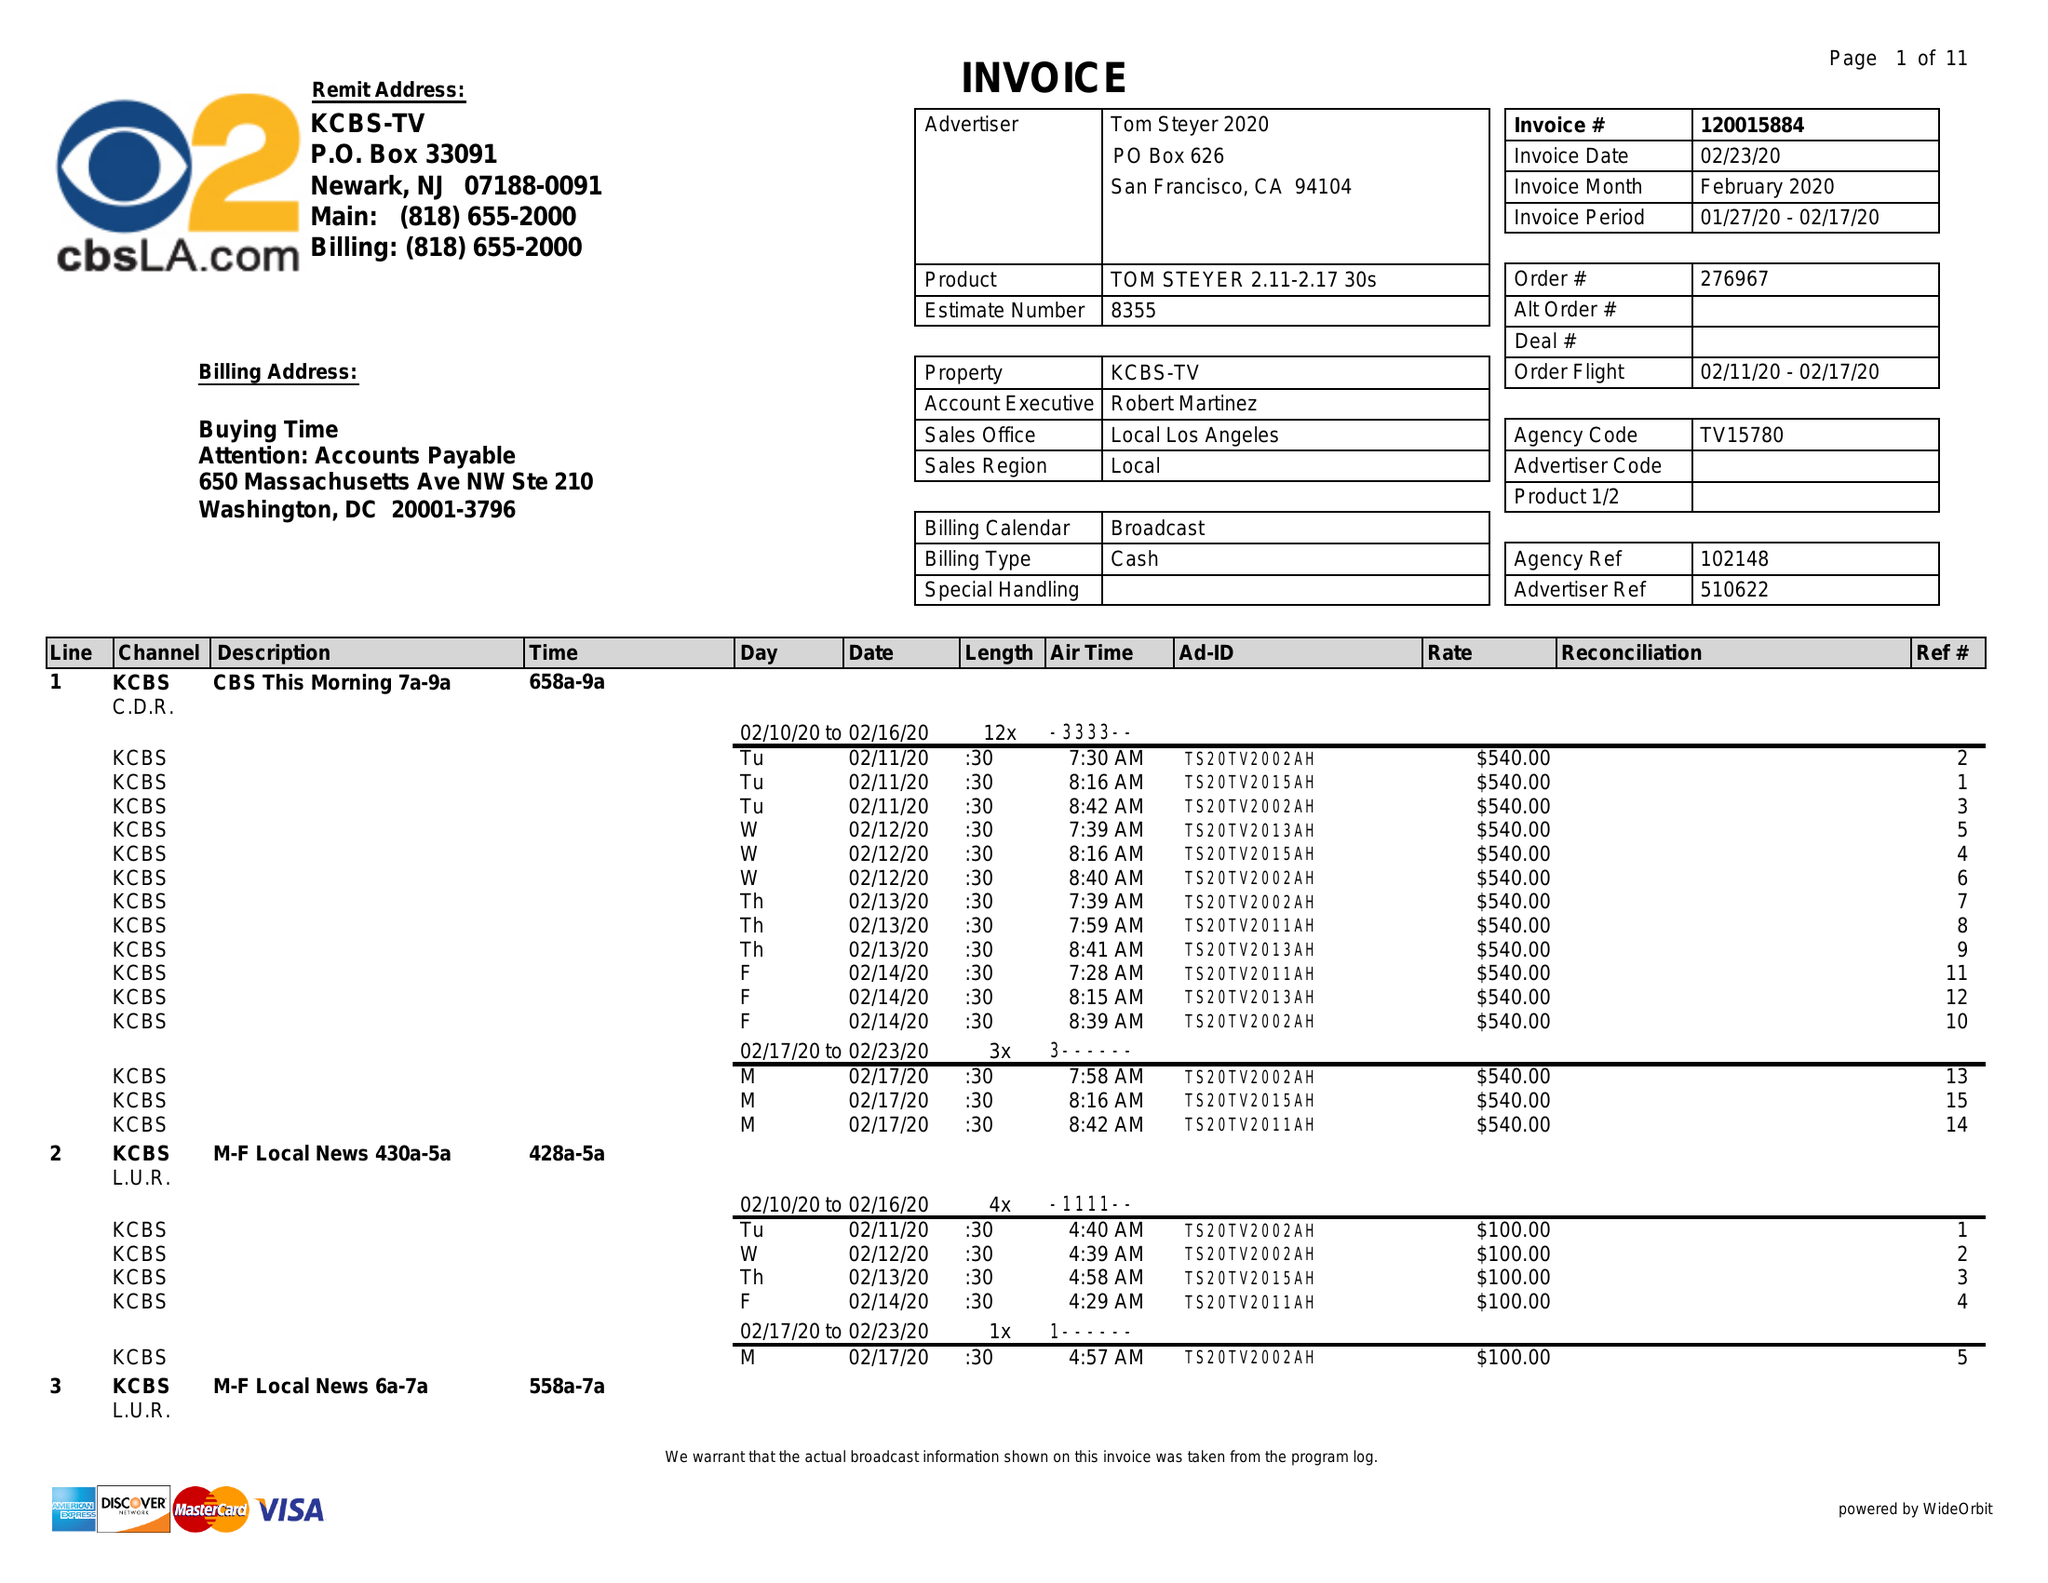What is the value for the flight_from?
Answer the question using a single word or phrase. 02/11/20 